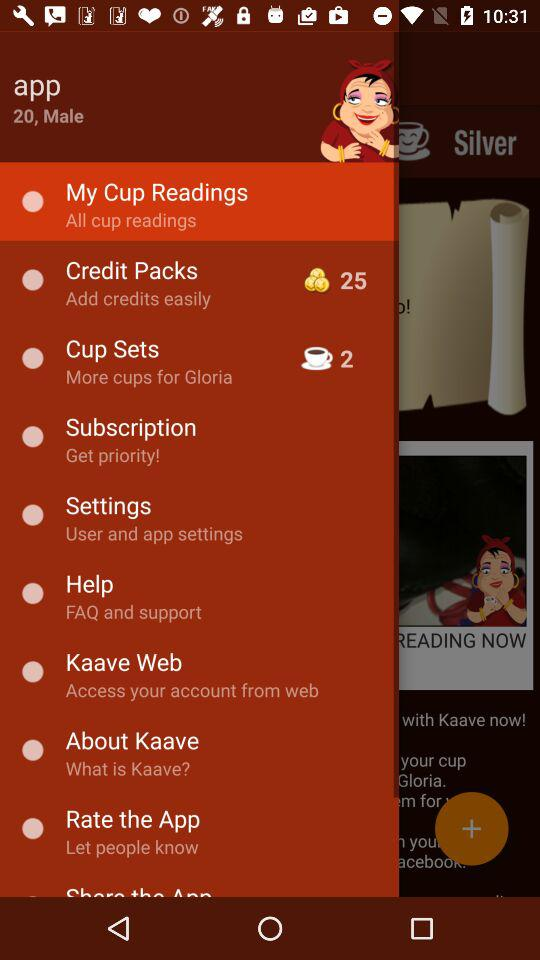Which option is selected? The selected option is "My Cup Readings". 